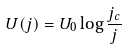<formula> <loc_0><loc_0><loc_500><loc_500>U ( j ) = U _ { 0 } \log \frac { j _ { c } } { j }</formula> 